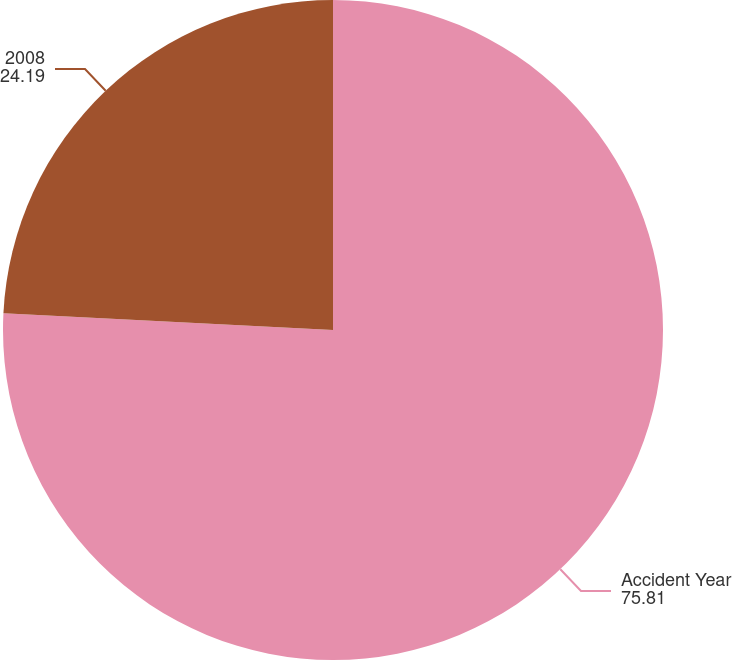Convert chart to OTSL. <chart><loc_0><loc_0><loc_500><loc_500><pie_chart><fcel>Accident Year<fcel>2008<nl><fcel>75.81%<fcel>24.19%<nl></chart> 